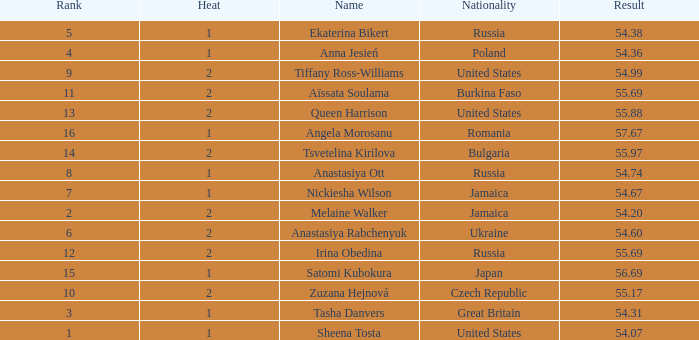Could you parse the entire table as a dict? {'header': ['Rank', 'Heat', 'Name', 'Nationality', 'Result'], 'rows': [['5', '1', 'Ekaterina Bikert', 'Russia', '54.38'], ['4', '1', 'Anna Jesień', 'Poland', '54.36'], ['9', '2', 'Tiffany Ross-Williams', 'United States', '54.99'], ['11', '2', 'Aïssata Soulama', 'Burkina Faso', '55.69'], ['13', '2', 'Queen Harrison', 'United States', '55.88'], ['16', '1', 'Angela Morosanu', 'Romania', '57.67'], ['14', '2', 'Tsvetelina Kirilova', 'Bulgaria', '55.97'], ['8', '1', 'Anastasiya Ott', 'Russia', '54.74'], ['7', '1', 'Nickiesha Wilson', 'Jamaica', '54.67'], ['2', '2', 'Melaine Walker', 'Jamaica', '54.20'], ['6', '2', 'Anastasiya Rabchenyuk', 'Ukraine', '54.60'], ['12', '2', 'Irina Obedina', 'Russia', '55.69'], ['15', '1', 'Satomi Kubokura', 'Japan', '56.69'], ['10', '2', 'Zuzana Hejnová', 'Czech Republic', '55.17'], ['3', '1', 'Tasha Danvers', 'Great Britain', '54.31'], ['1', '1', 'Sheena Tosta', 'United States', '54.07']]} Who has a Result of 54.67? Nickiesha Wilson. 